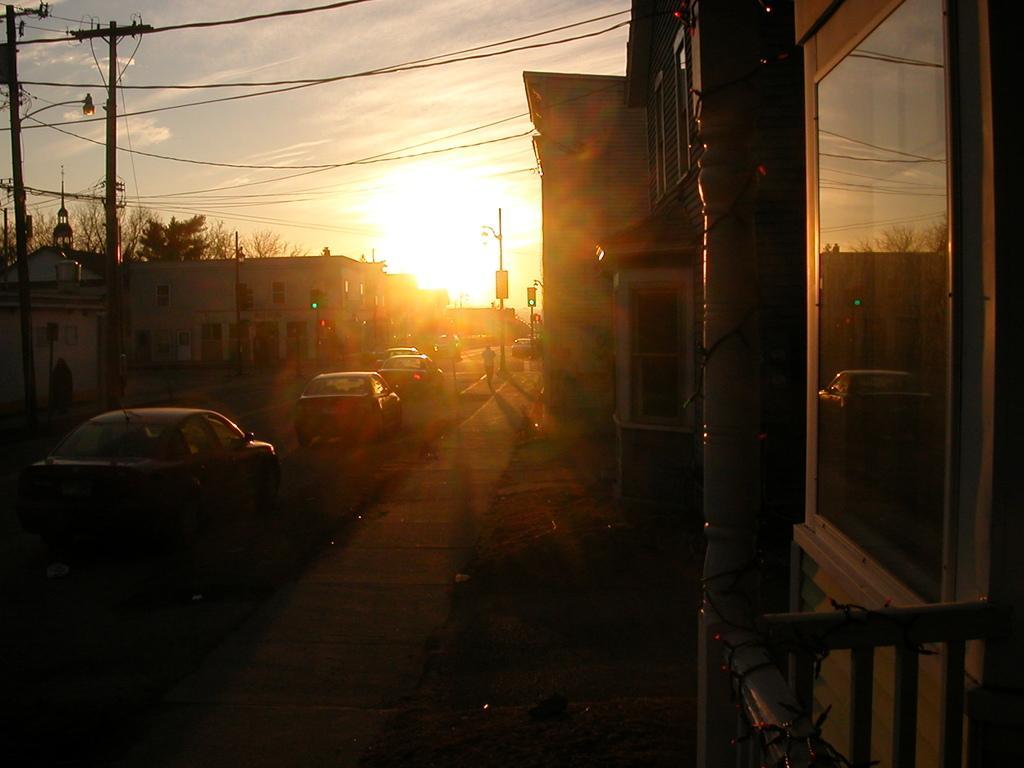Please provide a concise description of this image. In the center of the image there are cars on the road. There are traffic signals, lights, current poles. On both right and left side of the image there are buildings. In the background of the image there are trees and sky. 